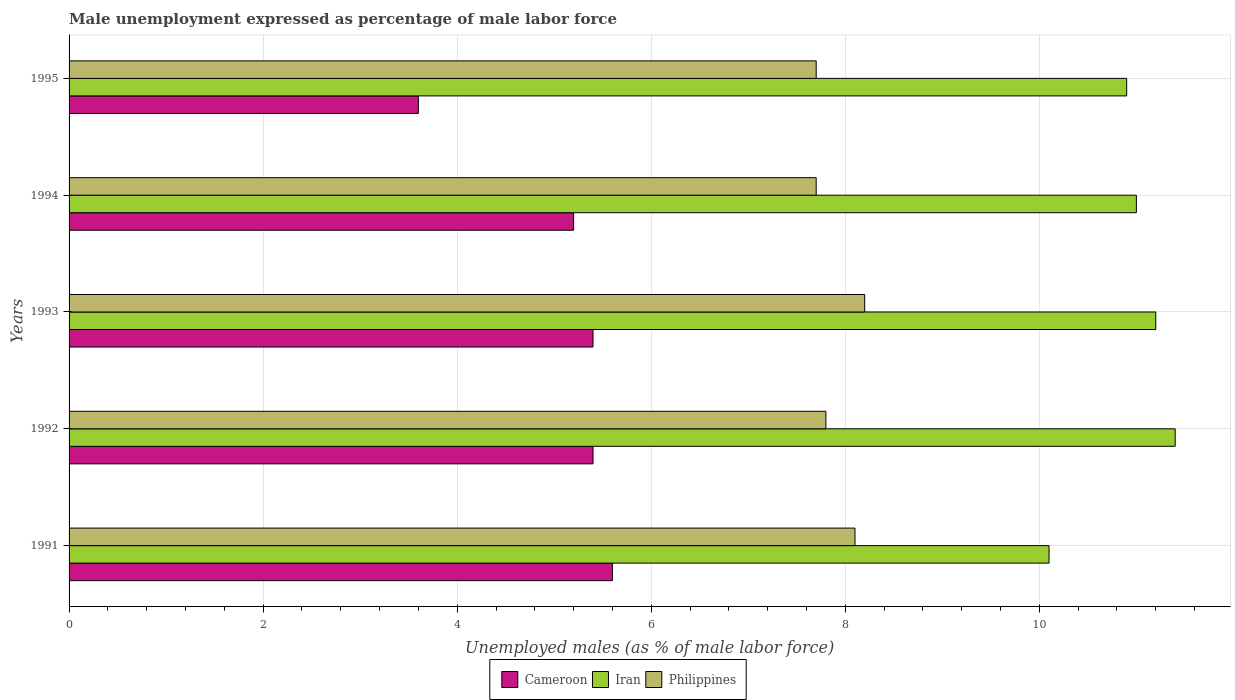How many groups of bars are there?
Your answer should be very brief. 5. Are the number of bars per tick equal to the number of legend labels?
Provide a short and direct response. Yes. Are the number of bars on each tick of the Y-axis equal?
Your answer should be compact. Yes. How many bars are there on the 4th tick from the bottom?
Give a very brief answer. 3. What is the unemployment in males in in Philippines in 1994?
Your answer should be compact. 7.7. Across all years, what is the maximum unemployment in males in in Cameroon?
Your answer should be compact. 5.6. Across all years, what is the minimum unemployment in males in in Cameroon?
Provide a short and direct response. 3.6. What is the total unemployment in males in in Cameroon in the graph?
Make the answer very short. 25.2. What is the difference between the unemployment in males in in Iran in 1991 and that in 1992?
Offer a terse response. -1.3. What is the difference between the unemployment in males in in Iran in 1992 and the unemployment in males in in Cameroon in 1995?
Provide a short and direct response. 7.8. What is the average unemployment in males in in Cameroon per year?
Offer a terse response. 5.04. In the year 1993, what is the difference between the unemployment in males in in Iran and unemployment in males in in Cameroon?
Provide a short and direct response. 5.8. What is the ratio of the unemployment in males in in Cameroon in 1993 to that in 1994?
Offer a terse response. 1.04. Is the unemployment in males in in Cameroon in 1991 less than that in 1992?
Make the answer very short. No. Is the difference between the unemployment in males in in Iran in 1991 and 1995 greater than the difference between the unemployment in males in in Cameroon in 1991 and 1995?
Your response must be concise. No. What is the difference between the highest and the second highest unemployment in males in in Philippines?
Offer a terse response. 0.1. What is the difference between the highest and the lowest unemployment in males in in Philippines?
Give a very brief answer. 0.5. Is the sum of the unemployment in males in in Iran in 1992 and 1993 greater than the maximum unemployment in males in in Cameroon across all years?
Offer a terse response. Yes. What does the 3rd bar from the top in 1993 represents?
Your answer should be very brief. Cameroon. What does the 2nd bar from the bottom in 1991 represents?
Your answer should be very brief. Iran. How many years are there in the graph?
Offer a very short reply. 5. What is the difference between two consecutive major ticks on the X-axis?
Your answer should be compact. 2. Are the values on the major ticks of X-axis written in scientific E-notation?
Give a very brief answer. No. Does the graph contain any zero values?
Give a very brief answer. No. Where does the legend appear in the graph?
Provide a short and direct response. Bottom center. What is the title of the graph?
Offer a terse response. Male unemployment expressed as percentage of male labor force. Does "Moldova" appear as one of the legend labels in the graph?
Make the answer very short. No. What is the label or title of the X-axis?
Give a very brief answer. Unemployed males (as % of male labor force). What is the label or title of the Y-axis?
Keep it short and to the point. Years. What is the Unemployed males (as % of male labor force) of Cameroon in 1991?
Provide a succinct answer. 5.6. What is the Unemployed males (as % of male labor force) of Iran in 1991?
Offer a very short reply. 10.1. What is the Unemployed males (as % of male labor force) in Philippines in 1991?
Provide a short and direct response. 8.1. What is the Unemployed males (as % of male labor force) in Cameroon in 1992?
Offer a very short reply. 5.4. What is the Unemployed males (as % of male labor force) of Iran in 1992?
Your answer should be compact. 11.4. What is the Unemployed males (as % of male labor force) in Philippines in 1992?
Ensure brevity in your answer.  7.8. What is the Unemployed males (as % of male labor force) in Cameroon in 1993?
Your answer should be compact. 5.4. What is the Unemployed males (as % of male labor force) of Iran in 1993?
Provide a succinct answer. 11.2. What is the Unemployed males (as % of male labor force) in Philippines in 1993?
Your answer should be very brief. 8.2. What is the Unemployed males (as % of male labor force) of Cameroon in 1994?
Give a very brief answer. 5.2. What is the Unemployed males (as % of male labor force) of Philippines in 1994?
Offer a terse response. 7.7. What is the Unemployed males (as % of male labor force) of Cameroon in 1995?
Your answer should be compact. 3.6. What is the Unemployed males (as % of male labor force) in Iran in 1995?
Your answer should be very brief. 10.9. What is the Unemployed males (as % of male labor force) in Philippines in 1995?
Your answer should be very brief. 7.7. Across all years, what is the maximum Unemployed males (as % of male labor force) in Cameroon?
Provide a short and direct response. 5.6. Across all years, what is the maximum Unemployed males (as % of male labor force) of Iran?
Offer a very short reply. 11.4. Across all years, what is the maximum Unemployed males (as % of male labor force) in Philippines?
Your answer should be compact. 8.2. Across all years, what is the minimum Unemployed males (as % of male labor force) of Cameroon?
Your answer should be very brief. 3.6. Across all years, what is the minimum Unemployed males (as % of male labor force) in Iran?
Keep it short and to the point. 10.1. Across all years, what is the minimum Unemployed males (as % of male labor force) of Philippines?
Provide a succinct answer. 7.7. What is the total Unemployed males (as % of male labor force) of Cameroon in the graph?
Give a very brief answer. 25.2. What is the total Unemployed males (as % of male labor force) in Iran in the graph?
Offer a terse response. 54.6. What is the total Unemployed males (as % of male labor force) in Philippines in the graph?
Make the answer very short. 39.5. What is the difference between the Unemployed males (as % of male labor force) in Philippines in 1991 and that in 1992?
Keep it short and to the point. 0.3. What is the difference between the Unemployed males (as % of male labor force) in Cameroon in 1991 and that in 1993?
Provide a succinct answer. 0.2. What is the difference between the Unemployed males (as % of male labor force) of Philippines in 1991 and that in 1993?
Your answer should be compact. -0.1. What is the difference between the Unemployed males (as % of male labor force) of Cameroon in 1991 and that in 1994?
Your answer should be very brief. 0.4. What is the difference between the Unemployed males (as % of male labor force) in Iran in 1991 and that in 1994?
Offer a very short reply. -0.9. What is the difference between the Unemployed males (as % of male labor force) of Philippines in 1991 and that in 1994?
Provide a short and direct response. 0.4. What is the difference between the Unemployed males (as % of male labor force) of Iran in 1991 and that in 1995?
Provide a succinct answer. -0.8. What is the difference between the Unemployed males (as % of male labor force) in Philippines in 1991 and that in 1995?
Give a very brief answer. 0.4. What is the difference between the Unemployed males (as % of male labor force) in Cameroon in 1992 and that in 1993?
Your answer should be very brief. 0. What is the difference between the Unemployed males (as % of male labor force) of Cameroon in 1992 and that in 1994?
Provide a short and direct response. 0.2. What is the difference between the Unemployed males (as % of male labor force) of Iran in 1992 and that in 1994?
Offer a terse response. 0.4. What is the difference between the Unemployed males (as % of male labor force) in Cameroon in 1992 and that in 1995?
Your answer should be compact. 1.8. What is the difference between the Unemployed males (as % of male labor force) in Iran in 1992 and that in 1995?
Keep it short and to the point. 0.5. What is the difference between the Unemployed males (as % of male labor force) of Philippines in 1992 and that in 1995?
Provide a short and direct response. 0.1. What is the difference between the Unemployed males (as % of male labor force) in Cameroon in 1993 and that in 1994?
Offer a terse response. 0.2. What is the difference between the Unemployed males (as % of male labor force) in Iran in 1993 and that in 1994?
Provide a short and direct response. 0.2. What is the difference between the Unemployed males (as % of male labor force) of Philippines in 1993 and that in 1994?
Your answer should be compact. 0.5. What is the difference between the Unemployed males (as % of male labor force) of Cameroon in 1993 and that in 1995?
Make the answer very short. 1.8. What is the difference between the Unemployed males (as % of male labor force) in Iran in 1993 and that in 1995?
Provide a short and direct response. 0.3. What is the difference between the Unemployed males (as % of male labor force) of Philippines in 1993 and that in 1995?
Provide a short and direct response. 0.5. What is the difference between the Unemployed males (as % of male labor force) of Cameroon in 1994 and that in 1995?
Offer a very short reply. 1.6. What is the difference between the Unemployed males (as % of male labor force) in Iran in 1994 and that in 1995?
Your response must be concise. 0.1. What is the difference between the Unemployed males (as % of male labor force) in Cameroon in 1991 and the Unemployed males (as % of male labor force) in Iran in 1993?
Ensure brevity in your answer.  -5.6. What is the difference between the Unemployed males (as % of male labor force) in Iran in 1991 and the Unemployed males (as % of male labor force) in Philippines in 1993?
Offer a terse response. 1.9. What is the difference between the Unemployed males (as % of male labor force) of Cameroon in 1991 and the Unemployed males (as % of male labor force) of Philippines in 1994?
Ensure brevity in your answer.  -2.1. What is the difference between the Unemployed males (as % of male labor force) in Iran in 1991 and the Unemployed males (as % of male labor force) in Philippines in 1994?
Your answer should be compact. 2.4. What is the difference between the Unemployed males (as % of male labor force) of Iran in 1991 and the Unemployed males (as % of male labor force) of Philippines in 1995?
Offer a terse response. 2.4. What is the difference between the Unemployed males (as % of male labor force) of Cameroon in 1992 and the Unemployed males (as % of male labor force) of Philippines in 1993?
Offer a terse response. -2.8. What is the difference between the Unemployed males (as % of male labor force) of Cameroon in 1992 and the Unemployed males (as % of male labor force) of Iran in 1994?
Your answer should be compact. -5.6. What is the difference between the Unemployed males (as % of male labor force) in Iran in 1992 and the Unemployed males (as % of male labor force) in Philippines in 1994?
Offer a terse response. 3.7. What is the difference between the Unemployed males (as % of male labor force) in Cameroon in 1992 and the Unemployed males (as % of male labor force) in Iran in 1995?
Your answer should be compact. -5.5. What is the difference between the Unemployed males (as % of male labor force) in Cameroon in 1992 and the Unemployed males (as % of male labor force) in Philippines in 1995?
Keep it short and to the point. -2.3. What is the difference between the Unemployed males (as % of male labor force) in Iran in 1992 and the Unemployed males (as % of male labor force) in Philippines in 1995?
Make the answer very short. 3.7. What is the difference between the Unemployed males (as % of male labor force) in Cameroon in 1993 and the Unemployed males (as % of male labor force) in Iran in 1994?
Ensure brevity in your answer.  -5.6. What is the difference between the Unemployed males (as % of male labor force) of Cameroon in 1993 and the Unemployed males (as % of male labor force) of Philippines in 1994?
Provide a succinct answer. -2.3. What is the difference between the Unemployed males (as % of male labor force) in Iran in 1993 and the Unemployed males (as % of male labor force) in Philippines in 1994?
Offer a terse response. 3.5. What is the difference between the Unemployed males (as % of male labor force) of Cameroon in 1993 and the Unemployed males (as % of male labor force) of Iran in 1995?
Your answer should be compact. -5.5. What is the difference between the Unemployed males (as % of male labor force) in Cameroon in 1993 and the Unemployed males (as % of male labor force) in Philippines in 1995?
Provide a succinct answer. -2.3. What is the average Unemployed males (as % of male labor force) in Cameroon per year?
Your answer should be very brief. 5.04. What is the average Unemployed males (as % of male labor force) in Iran per year?
Your response must be concise. 10.92. What is the average Unemployed males (as % of male labor force) in Philippines per year?
Your answer should be compact. 7.9. In the year 1991, what is the difference between the Unemployed males (as % of male labor force) in Cameroon and Unemployed males (as % of male labor force) in Iran?
Offer a very short reply. -4.5. In the year 1991, what is the difference between the Unemployed males (as % of male labor force) of Iran and Unemployed males (as % of male labor force) of Philippines?
Provide a succinct answer. 2. In the year 1992, what is the difference between the Unemployed males (as % of male labor force) of Cameroon and Unemployed males (as % of male labor force) of Iran?
Your answer should be very brief. -6. In the year 1992, what is the difference between the Unemployed males (as % of male labor force) in Cameroon and Unemployed males (as % of male labor force) in Philippines?
Provide a short and direct response. -2.4. In the year 1993, what is the difference between the Unemployed males (as % of male labor force) of Cameroon and Unemployed males (as % of male labor force) of Philippines?
Provide a short and direct response. -2.8. In the year 1993, what is the difference between the Unemployed males (as % of male labor force) of Iran and Unemployed males (as % of male labor force) of Philippines?
Provide a succinct answer. 3. In the year 1994, what is the difference between the Unemployed males (as % of male labor force) in Cameroon and Unemployed males (as % of male labor force) in Philippines?
Your answer should be very brief. -2.5. In the year 1994, what is the difference between the Unemployed males (as % of male labor force) in Iran and Unemployed males (as % of male labor force) in Philippines?
Offer a terse response. 3.3. In the year 1995, what is the difference between the Unemployed males (as % of male labor force) in Iran and Unemployed males (as % of male labor force) in Philippines?
Your answer should be very brief. 3.2. What is the ratio of the Unemployed males (as % of male labor force) in Iran in 1991 to that in 1992?
Give a very brief answer. 0.89. What is the ratio of the Unemployed males (as % of male labor force) in Philippines in 1991 to that in 1992?
Keep it short and to the point. 1.04. What is the ratio of the Unemployed males (as % of male labor force) in Iran in 1991 to that in 1993?
Provide a short and direct response. 0.9. What is the ratio of the Unemployed males (as % of male labor force) in Cameroon in 1991 to that in 1994?
Provide a succinct answer. 1.08. What is the ratio of the Unemployed males (as % of male labor force) in Iran in 1991 to that in 1994?
Your answer should be very brief. 0.92. What is the ratio of the Unemployed males (as % of male labor force) in Philippines in 1991 to that in 1994?
Keep it short and to the point. 1.05. What is the ratio of the Unemployed males (as % of male labor force) in Cameroon in 1991 to that in 1995?
Keep it short and to the point. 1.56. What is the ratio of the Unemployed males (as % of male labor force) of Iran in 1991 to that in 1995?
Offer a very short reply. 0.93. What is the ratio of the Unemployed males (as % of male labor force) in Philippines in 1991 to that in 1995?
Offer a terse response. 1.05. What is the ratio of the Unemployed males (as % of male labor force) in Iran in 1992 to that in 1993?
Offer a terse response. 1.02. What is the ratio of the Unemployed males (as % of male labor force) of Philippines in 1992 to that in 1993?
Make the answer very short. 0.95. What is the ratio of the Unemployed males (as % of male labor force) of Cameroon in 1992 to that in 1994?
Your response must be concise. 1.04. What is the ratio of the Unemployed males (as % of male labor force) of Iran in 1992 to that in 1994?
Provide a short and direct response. 1.04. What is the ratio of the Unemployed males (as % of male labor force) of Iran in 1992 to that in 1995?
Your response must be concise. 1.05. What is the ratio of the Unemployed males (as % of male labor force) of Cameroon in 1993 to that in 1994?
Your answer should be compact. 1.04. What is the ratio of the Unemployed males (as % of male labor force) in Iran in 1993 to that in 1994?
Offer a very short reply. 1.02. What is the ratio of the Unemployed males (as % of male labor force) in Philippines in 1993 to that in 1994?
Ensure brevity in your answer.  1.06. What is the ratio of the Unemployed males (as % of male labor force) in Iran in 1993 to that in 1995?
Your answer should be very brief. 1.03. What is the ratio of the Unemployed males (as % of male labor force) in Philippines in 1993 to that in 1995?
Offer a very short reply. 1.06. What is the ratio of the Unemployed males (as % of male labor force) of Cameroon in 1994 to that in 1995?
Offer a very short reply. 1.44. What is the ratio of the Unemployed males (as % of male labor force) in Iran in 1994 to that in 1995?
Provide a succinct answer. 1.01. What is the difference between the highest and the second highest Unemployed males (as % of male labor force) of Cameroon?
Your response must be concise. 0.2. What is the difference between the highest and the second highest Unemployed males (as % of male labor force) in Iran?
Offer a terse response. 0.2. What is the difference between the highest and the second highest Unemployed males (as % of male labor force) in Philippines?
Give a very brief answer. 0.1. What is the difference between the highest and the lowest Unemployed males (as % of male labor force) in Cameroon?
Provide a short and direct response. 2. What is the difference between the highest and the lowest Unemployed males (as % of male labor force) in Iran?
Your response must be concise. 1.3. 